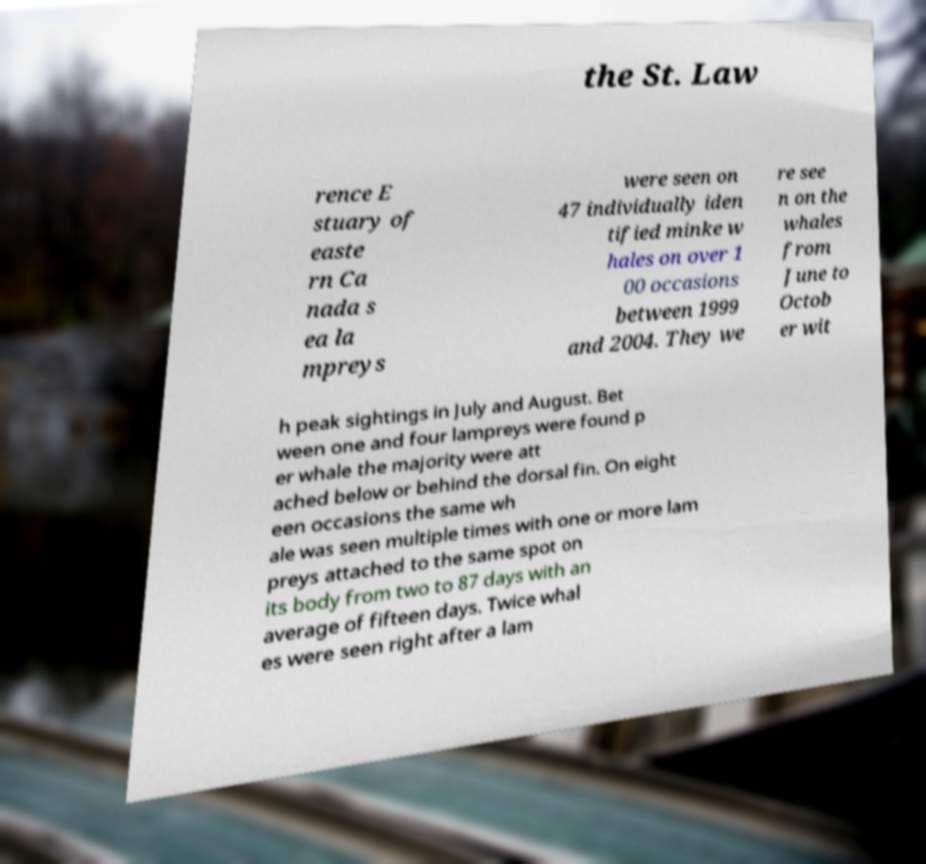Can you accurately transcribe the text from the provided image for me? the St. Law rence E stuary of easte rn Ca nada s ea la mpreys were seen on 47 individually iden tified minke w hales on over 1 00 occasions between 1999 and 2004. They we re see n on the whales from June to Octob er wit h peak sightings in July and August. Bet ween one and four lampreys were found p er whale the majority were att ached below or behind the dorsal fin. On eight een occasions the same wh ale was seen multiple times with one or more lam preys attached to the same spot on its body from two to 87 days with an average of fifteen days. Twice whal es were seen right after a lam 